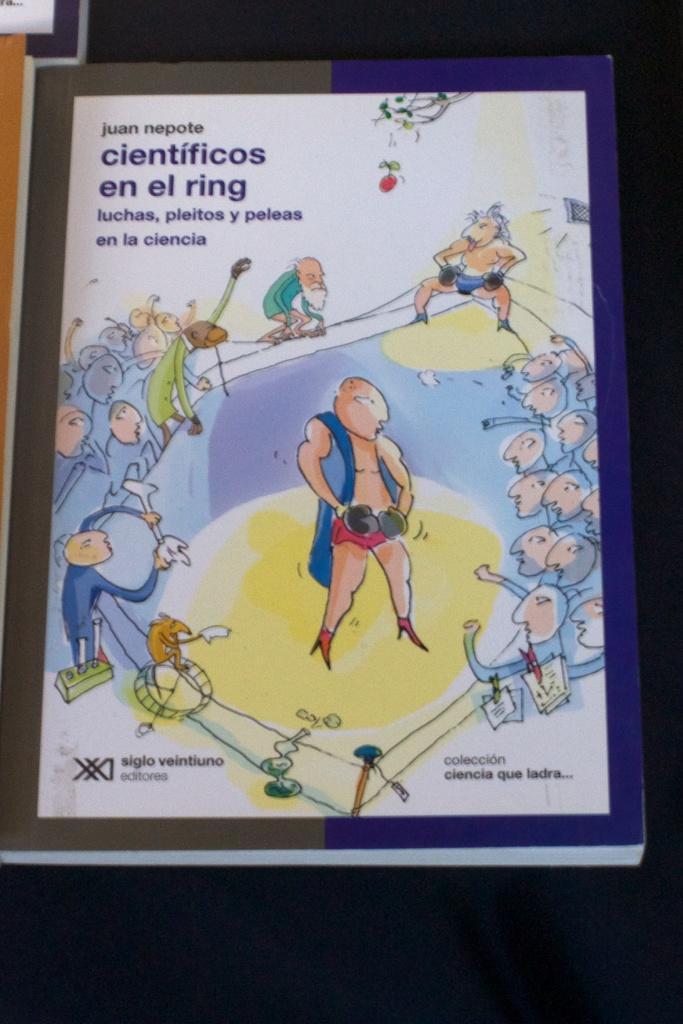Describe this image in one or two sentences. In this image there is a book in the middle. On the book cover page there is a man standing in the middle by wearing the gloves. There are few people around him who are cheering. 